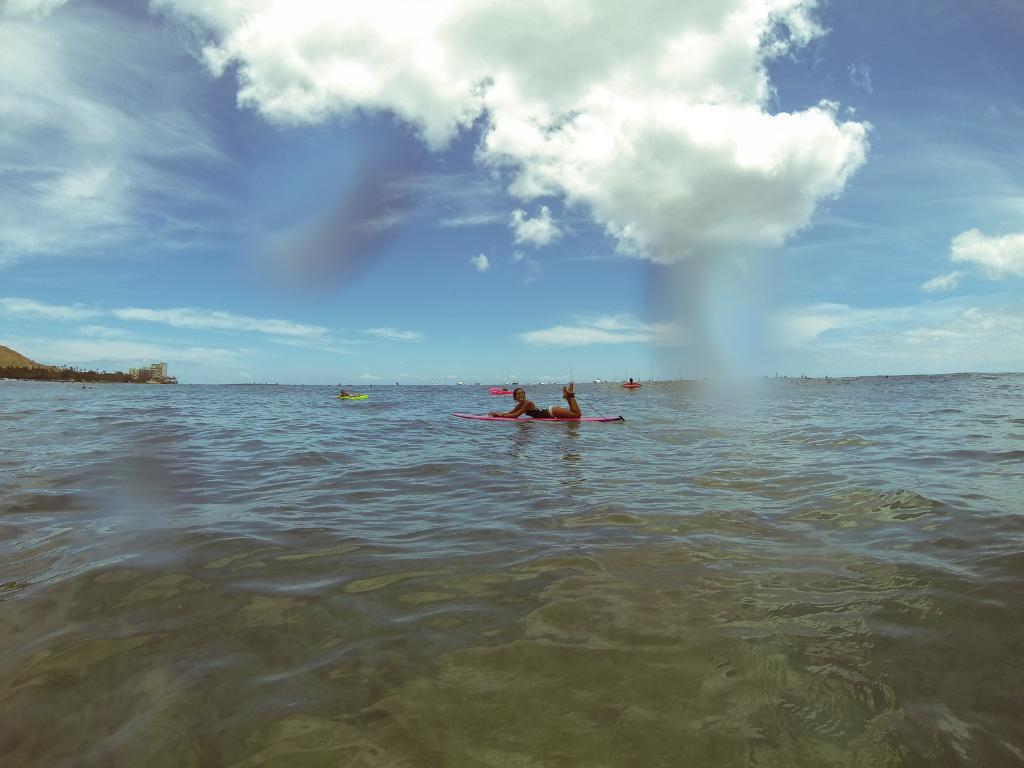What is the main subject of the image? The main subject of the image is a person lying on a surfboard on the water. What is the person doing on the water? The person is surfing on a surfboard. What can be seen in the background of the image? The sky is visible in the background of the image, and there are clouds in the sky. Are there any other surfboards in the image? Yes, there are surfboards in the water in the background of the image. Can you tell me how many times the person on the surfboard coughs in the image? There is no indication of the person coughing in the image, so it cannot be determined. What type of chain is wrapped around the person's eye in the image? There is no chain or any reference to an eye in the image; it features a person surfing on a surfboard. 